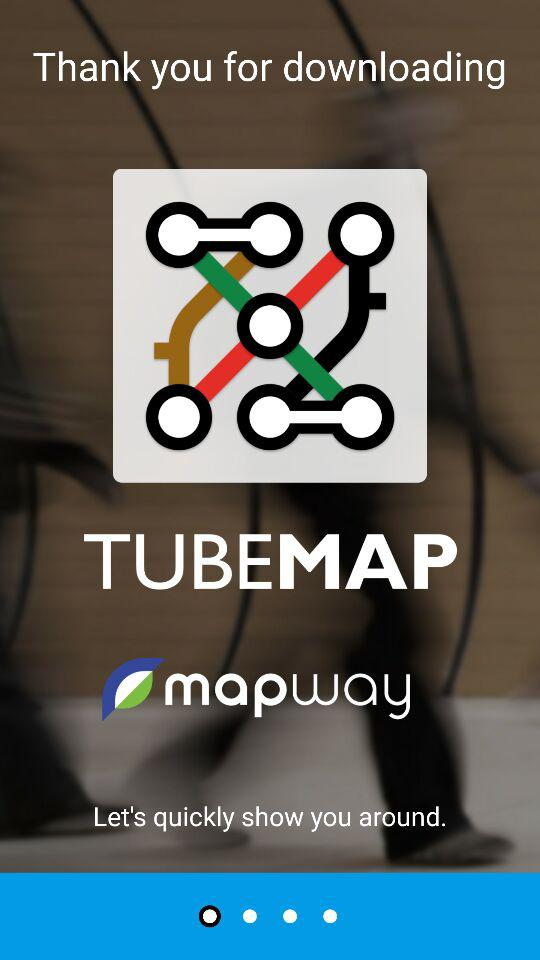What is the name of the application? The name of the application is "Tube Map - London Underground". 